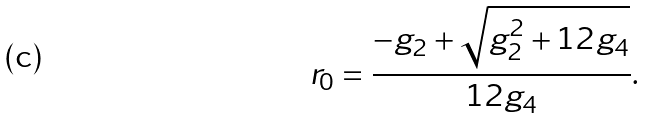<formula> <loc_0><loc_0><loc_500><loc_500>r _ { 0 } = \frac { - g _ { 2 } + \sqrt { g _ { 2 } ^ { 2 } + 1 2 g _ { 4 } } } { 1 2 g _ { 4 } } .</formula> 